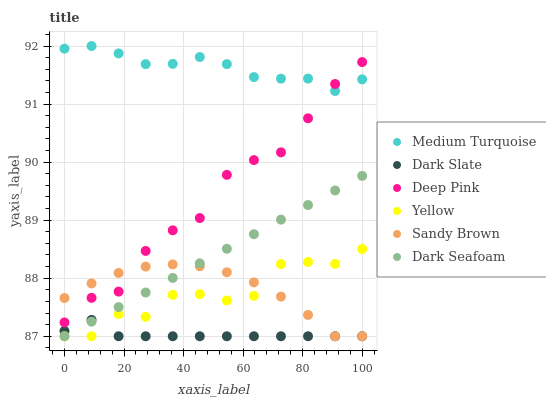Does Dark Slate have the minimum area under the curve?
Answer yes or no. Yes. Does Medium Turquoise have the maximum area under the curve?
Answer yes or no. Yes. Does Yellow have the minimum area under the curve?
Answer yes or no. No. Does Yellow have the maximum area under the curve?
Answer yes or no. No. Is Dark Seafoam the smoothest?
Answer yes or no. Yes. Is Yellow the roughest?
Answer yes or no. Yes. Is Dark Slate the smoothest?
Answer yes or no. No. Is Dark Slate the roughest?
Answer yes or no. No. Does Yellow have the lowest value?
Answer yes or no. Yes. Does Medium Turquoise have the lowest value?
Answer yes or no. No. Does Medium Turquoise have the highest value?
Answer yes or no. Yes. Does Yellow have the highest value?
Answer yes or no. No. Is Dark Slate less than Medium Turquoise?
Answer yes or no. Yes. Is Deep Pink greater than Dark Seafoam?
Answer yes or no. Yes. Does Sandy Brown intersect Dark Slate?
Answer yes or no. Yes. Is Sandy Brown less than Dark Slate?
Answer yes or no. No. Is Sandy Brown greater than Dark Slate?
Answer yes or no. No. Does Dark Slate intersect Medium Turquoise?
Answer yes or no. No. 